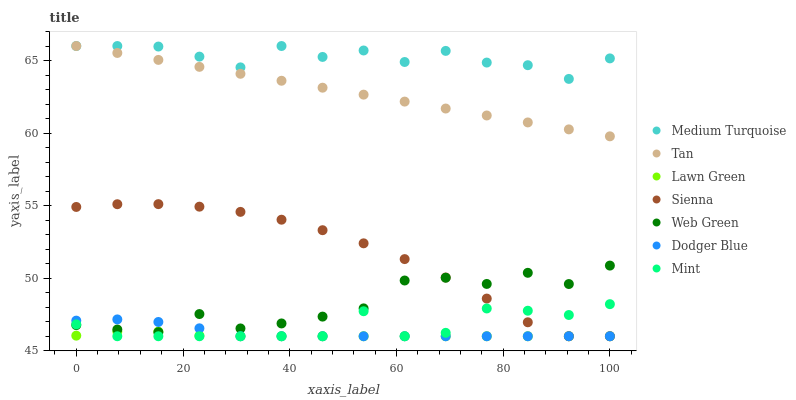Does Lawn Green have the minimum area under the curve?
Answer yes or no. Yes. Does Medium Turquoise have the maximum area under the curve?
Answer yes or no. Yes. Does Web Green have the minimum area under the curve?
Answer yes or no. No. Does Web Green have the maximum area under the curve?
Answer yes or no. No. Is Tan the smoothest?
Answer yes or no. Yes. Is Medium Turquoise the roughest?
Answer yes or no. Yes. Is Web Green the smoothest?
Answer yes or no. No. Is Web Green the roughest?
Answer yes or no. No. Does Lawn Green have the lowest value?
Answer yes or no. Yes. Does Web Green have the lowest value?
Answer yes or no. No. Does Tan have the highest value?
Answer yes or no. Yes. Does Web Green have the highest value?
Answer yes or no. No. Is Lawn Green less than Medium Turquoise?
Answer yes or no. Yes. Is Tan greater than Lawn Green?
Answer yes or no. Yes. Does Mint intersect Lawn Green?
Answer yes or no. Yes. Is Mint less than Lawn Green?
Answer yes or no. No. Is Mint greater than Lawn Green?
Answer yes or no. No. Does Lawn Green intersect Medium Turquoise?
Answer yes or no. No. 